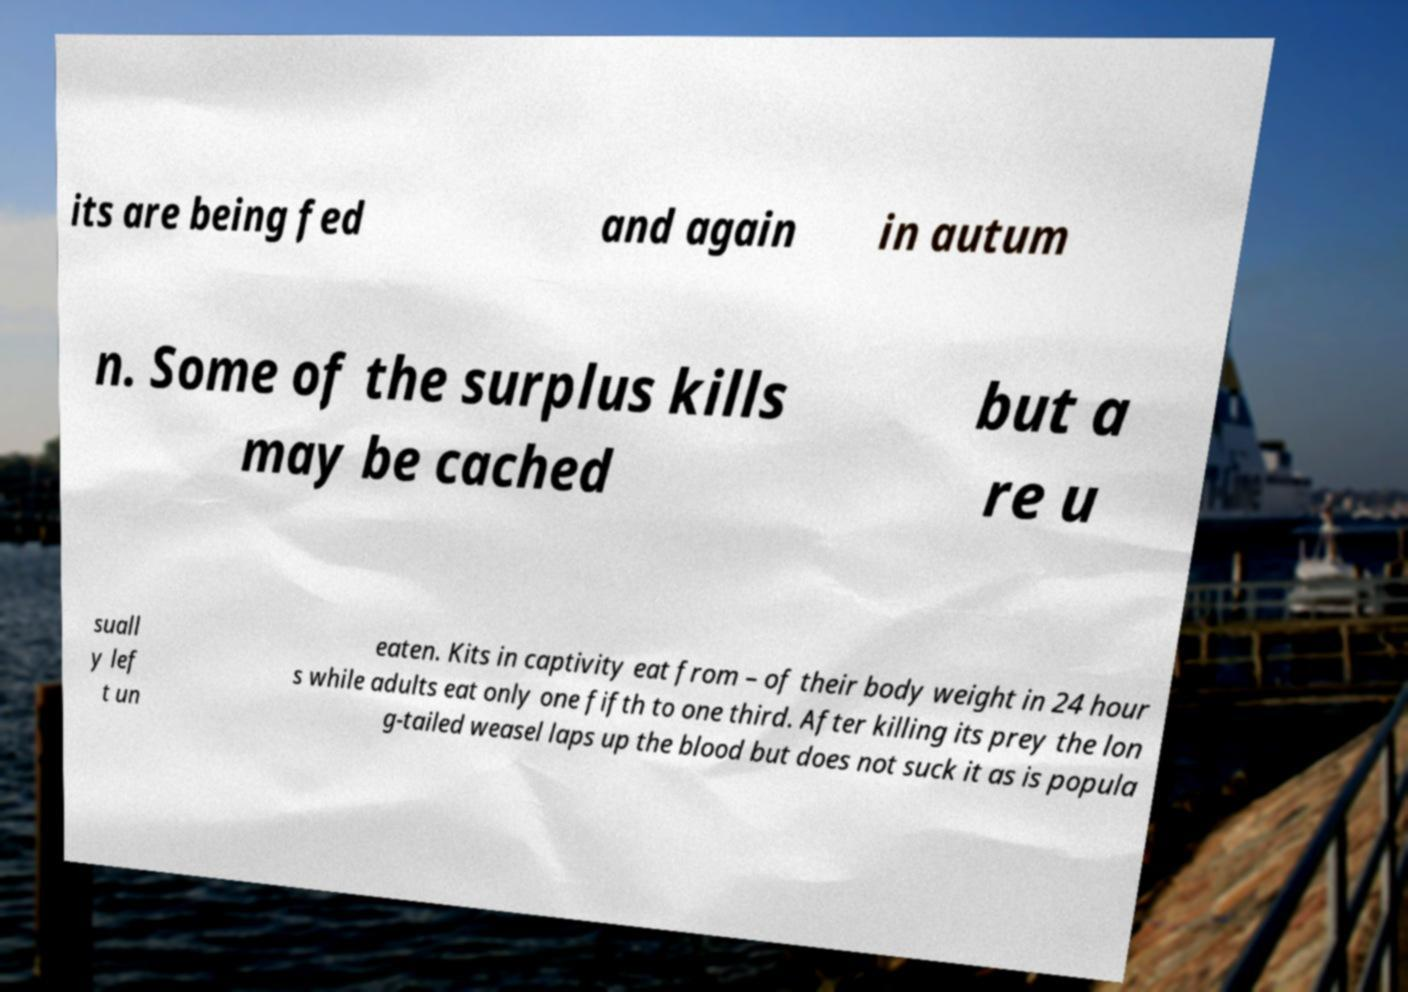Could you extract and type out the text from this image? its are being fed and again in autum n. Some of the surplus kills may be cached but a re u suall y lef t un eaten. Kits in captivity eat from – of their body weight in 24 hour s while adults eat only one fifth to one third. After killing its prey the lon g-tailed weasel laps up the blood but does not suck it as is popula 